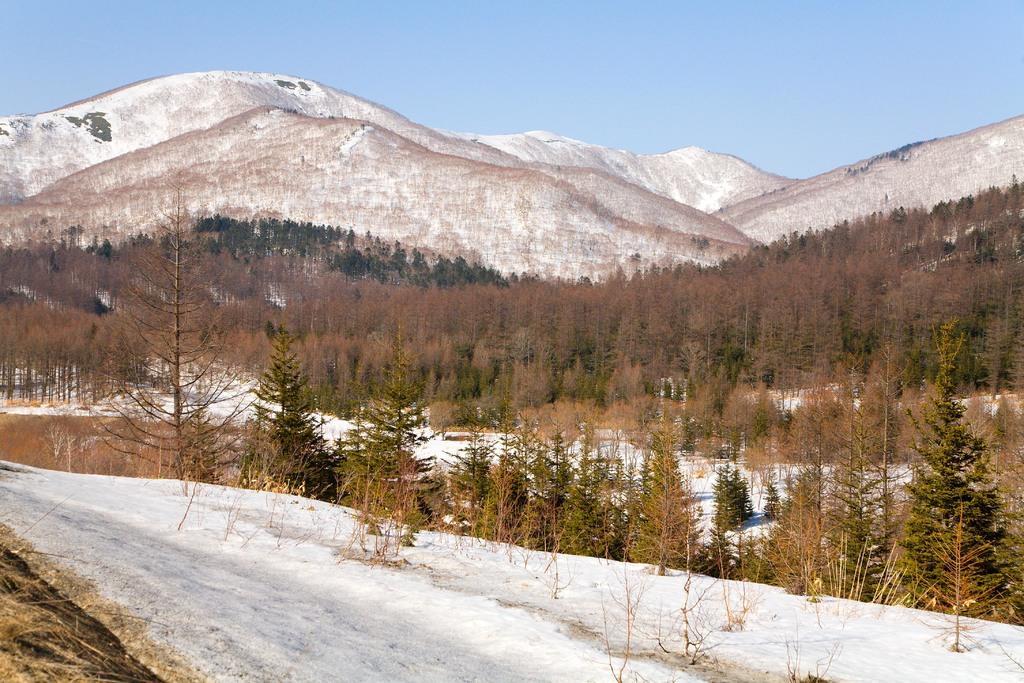In one or two sentences, can you explain what this image depicts? In the picture we can see a snow pathway on it, we can see some plants and beside it also we can see some plants and trees and behind it, we can see some part of the snow and behind it, we can see full of trees and hills with a snow and behind it we can see a sky. 